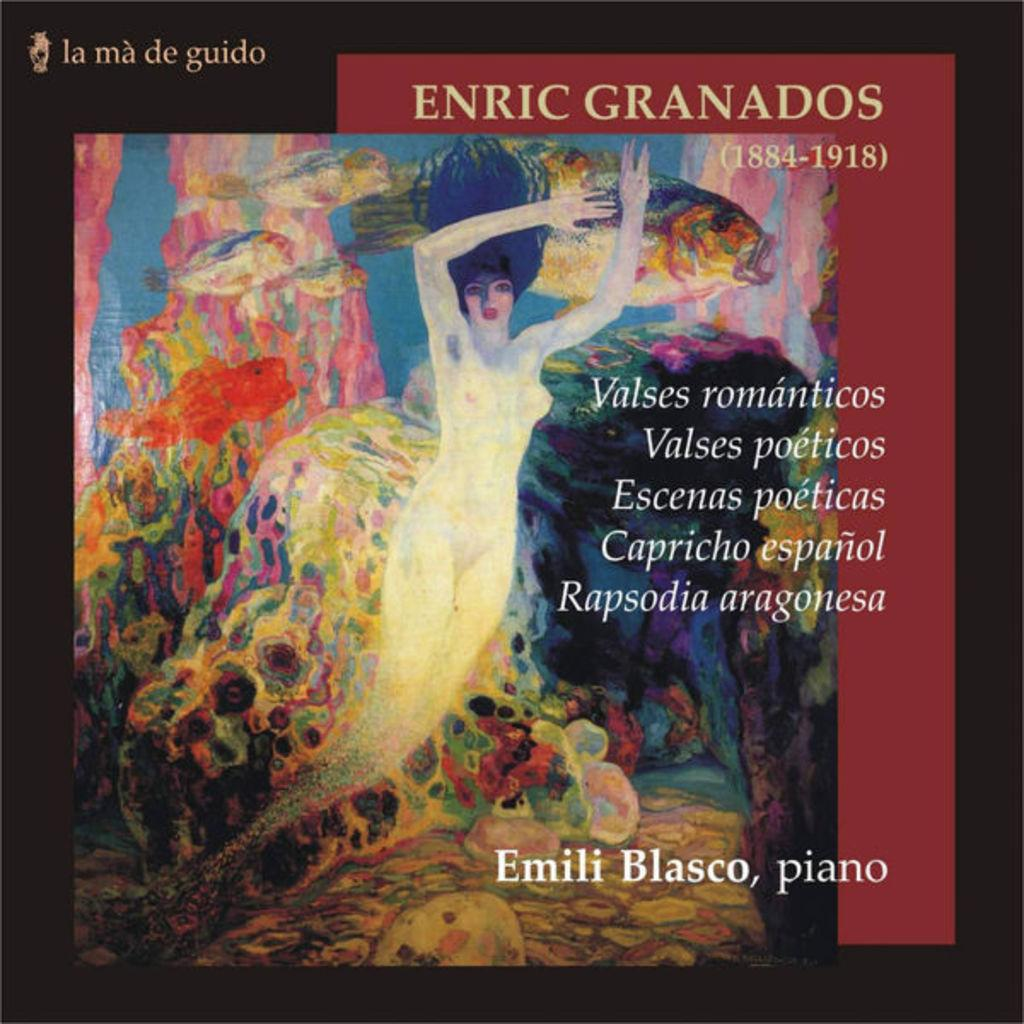<image>
Render a clear and concise summary of the photo. The album features Emili Blasco on the piano. 